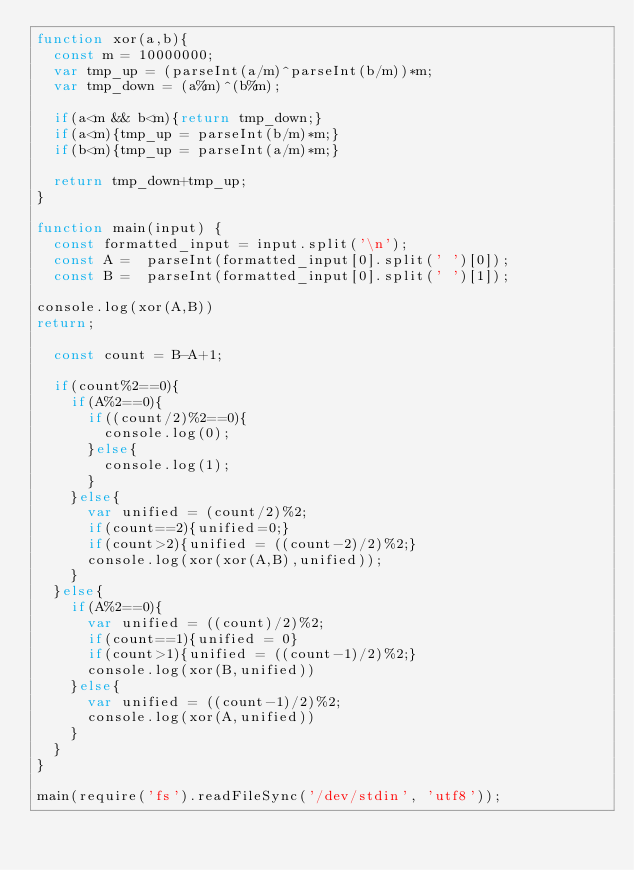<code> <loc_0><loc_0><loc_500><loc_500><_JavaScript_>function xor(a,b){
  const m = 10000000;
  var tmp_up = (parseInt(a/m)^parseInt(b/m))*m;
  var tmp_down = (a%m)^(b%m);

  if(a<m && b<m){return tmp_down;}
  if(a<m){tmp_up = parseInt(b/m)*m;}
  if(b<m){tmp_up = parseInt(a/m)*m;}

  return tmp_down+tmp_up;
}

function main(input) {
  const formatted_input = input.split('\n');
  const A =  parseInt(formatted_input[0].split(' ')[0]);
  const B =  parseInt(formatted_input[0].split(' ')[1]);

console.log(xor(A,B))
return;

  const count = B-A+1;

  if(count%2==0){
    if(A%2==0){
      if((count/2)%2==0){
        console.log(0);
      }else{
        console.log(1);
      }
    }else{
      var unified = (count/2)%2;
      if(count==2){unified=0;}
      if(count>2){unified = ((count-2)/2)%2;}
      console.log(xor(xor(A,B),unified));
    }
  }else{
    if(A%2==0){
      var unified = ((count)/2)%2;
      if(count==1){unified = 0}
      if(count>1){unified = ((count-1)/2)%2;}
      console.log(xor(B,unified))
    }else{
      var unified = ((count-1)/2)%2;
      console.log(xor(A,unified))
    }
  }
}

main(require('fs').readFileSync('/dev/stdin', 'utf8'));

</code> 